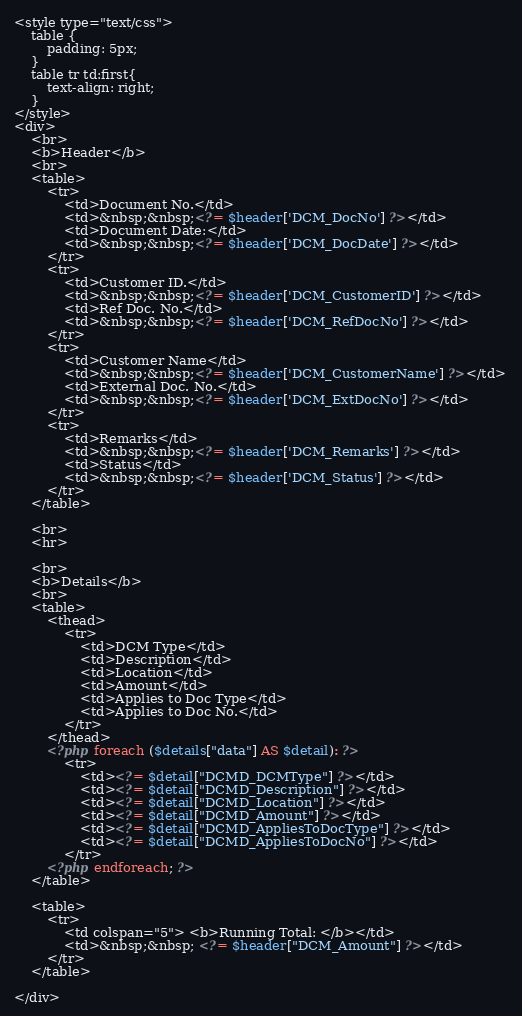Convert code to text. <code><loc_0><loc_0><loc_500><loc_500><_PHP_><style type="text/css">
    table {
        padding: 5px;
    }
    table tr td:first{
        text-align: right;
    }
</style>
<div>
    <br>
    <b>Header</b>
    <br>
    <table>
        <tr>
            <td>Document No.</td>
            <td>&nbsp;&nbsp;<?= $header['DCM_DocNo'] ?></td>
            <td>Document Date:</td>
            <td>&nbsp;&nbsp;<?= $header['DCM_DocDate'] ?></td>            
        </tr>
        <tr>
            <td>Customer ID.</td>
            <td>&nbsp;&nbsp;<?= $header['DCM_CustomerID'] ?></td>
            <td>Ref Doc. No.</td>
            <td>&nbsp;&nbsp;<?= $header['DCM_RefDocNo'] ?></td>
        </tr>
        <tr>
            <td>Customer Name</td>
            <td>&nbsp;&nbsp;<?= $header['DCM_CustomerName'] ?></td>
            <td>External Doc. No.</td>
            <td>&nbsp;&nbsp;<?= $header['DCM_ExtDocNo'] ?></td>
        </tr>
        <tr>
            <td>Remarks</td>
            <td>&nbsp;&nbsp;<?= $header['DCM_Remarks'] ?></td>
            <td>Status</td>
            <td>&nbsp;&nbsp;<?= $header['DCM_Status'] ?></td>
        </tr>
    </table>

    <br>
    <hr>

    <br>
    <b>Details</b>
    <br>
    <table>
        <thead>
            <tr>
                <td>DCM Type</td>
                <td>Description</td>
                <td>Location</td>
                <td>Amount</td>
                <td>Applies to Doc Type</td>
                <td>Applies to Doc No.</td>
            </tr>
        </thead>
        <?php foreach ($details["data"] AS $detail): ?>
            <tr>
                <td><?= $detail["DCMD_DCMType"] ?></td>
                <td><?= $detail["DCMD_Description"] ?></td>
                <td><?= $detail["DCMD_Location"] ?></td>
                <td><?= $detail["DCMD_Amount"] ?></td>
                <td><?= $detail["DCMD_AppliesToDocType"] ?></td>
                <td><?= $detail["DCMD_AppliesToDocNo"] ?></td>
            </tr>
        <?php endforeach; ?>
    </table>

    <table>
        <tr>            
            <td colspan="5"> <b>Running Total: </b></td>
            <td>&nbsp;&nbsp; <?= $header["DCM_Amount"] ?></td>
        </tr>
    </table>

</div>
</code> 